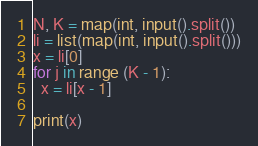<code> <loc_0><loc_0><loc_500><loc_500><_Python_>N, K = map(int, input().split())
li = list(map(int, input().split()))
x = li[0]
for j in range (K - 1):
  x = li[x - 1]

print(x)</code> 